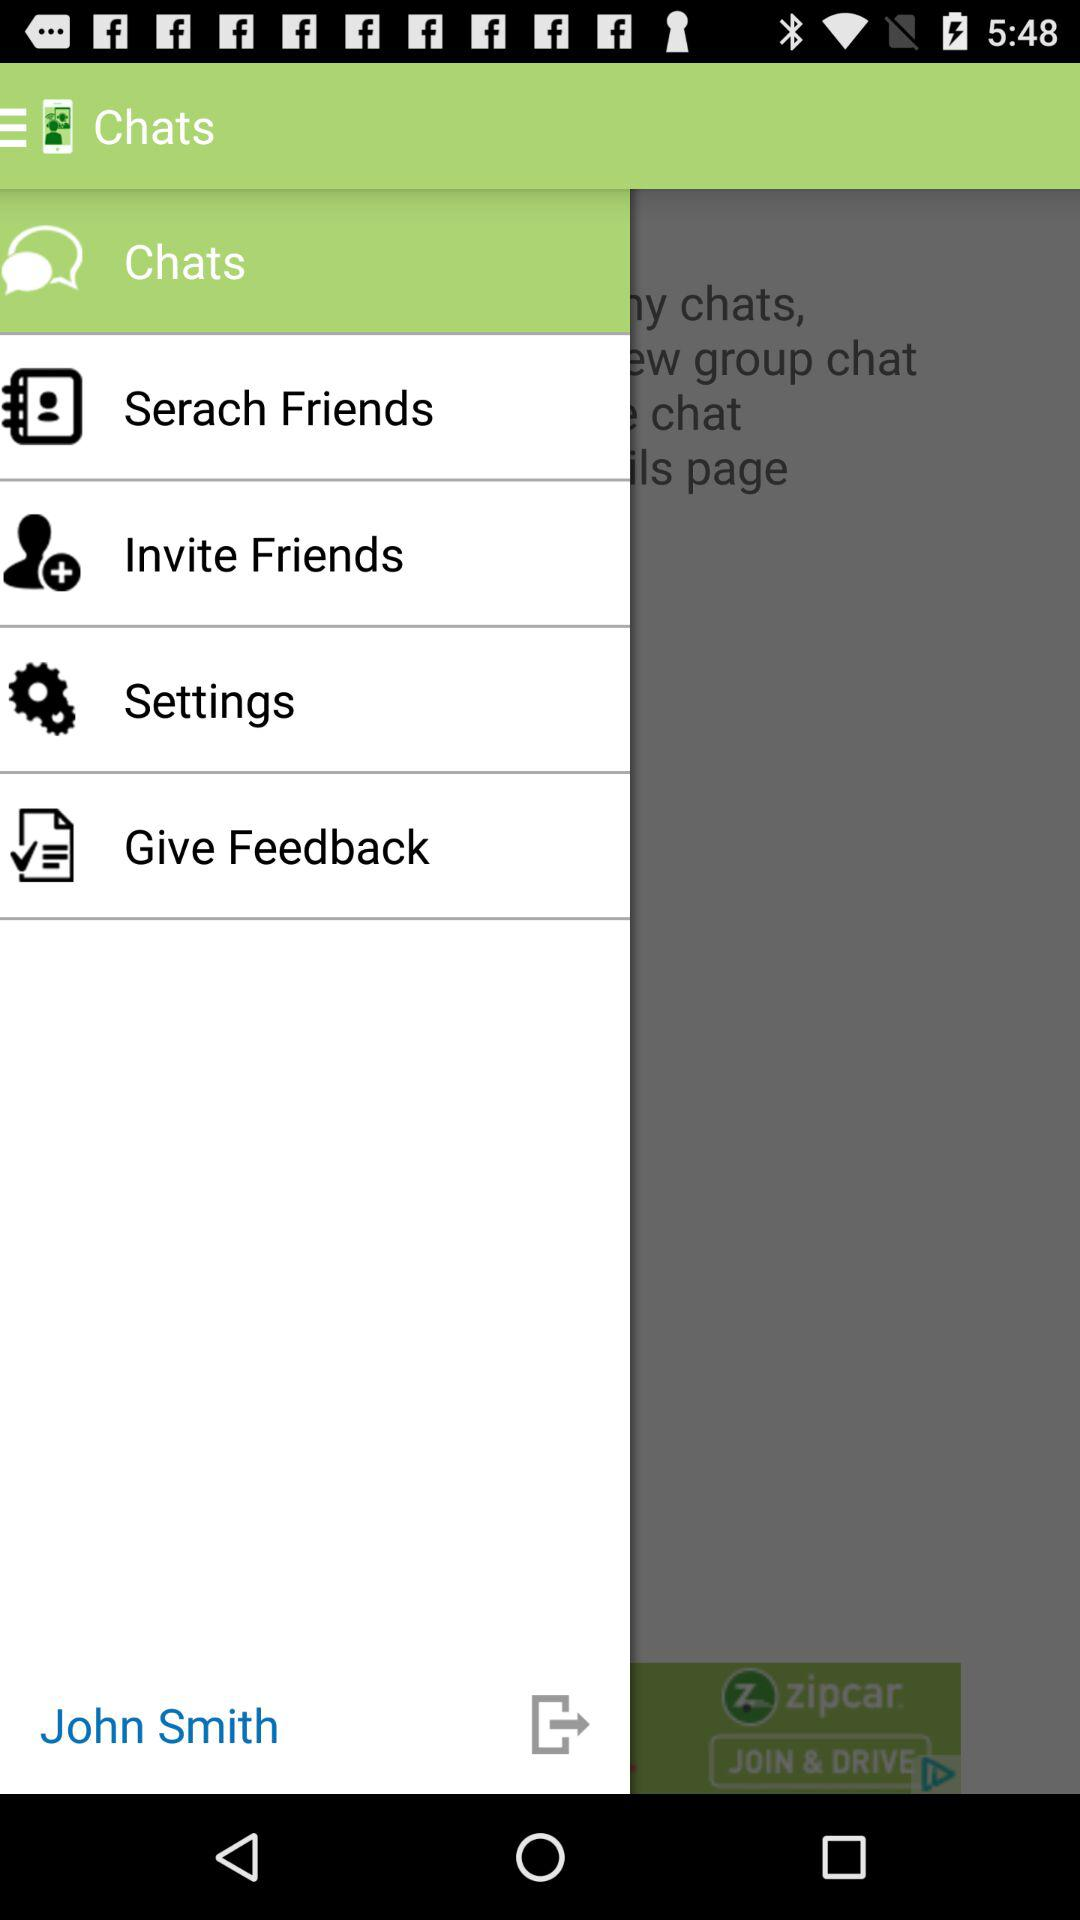What is the name of the user? The name of the user is John Smith. 